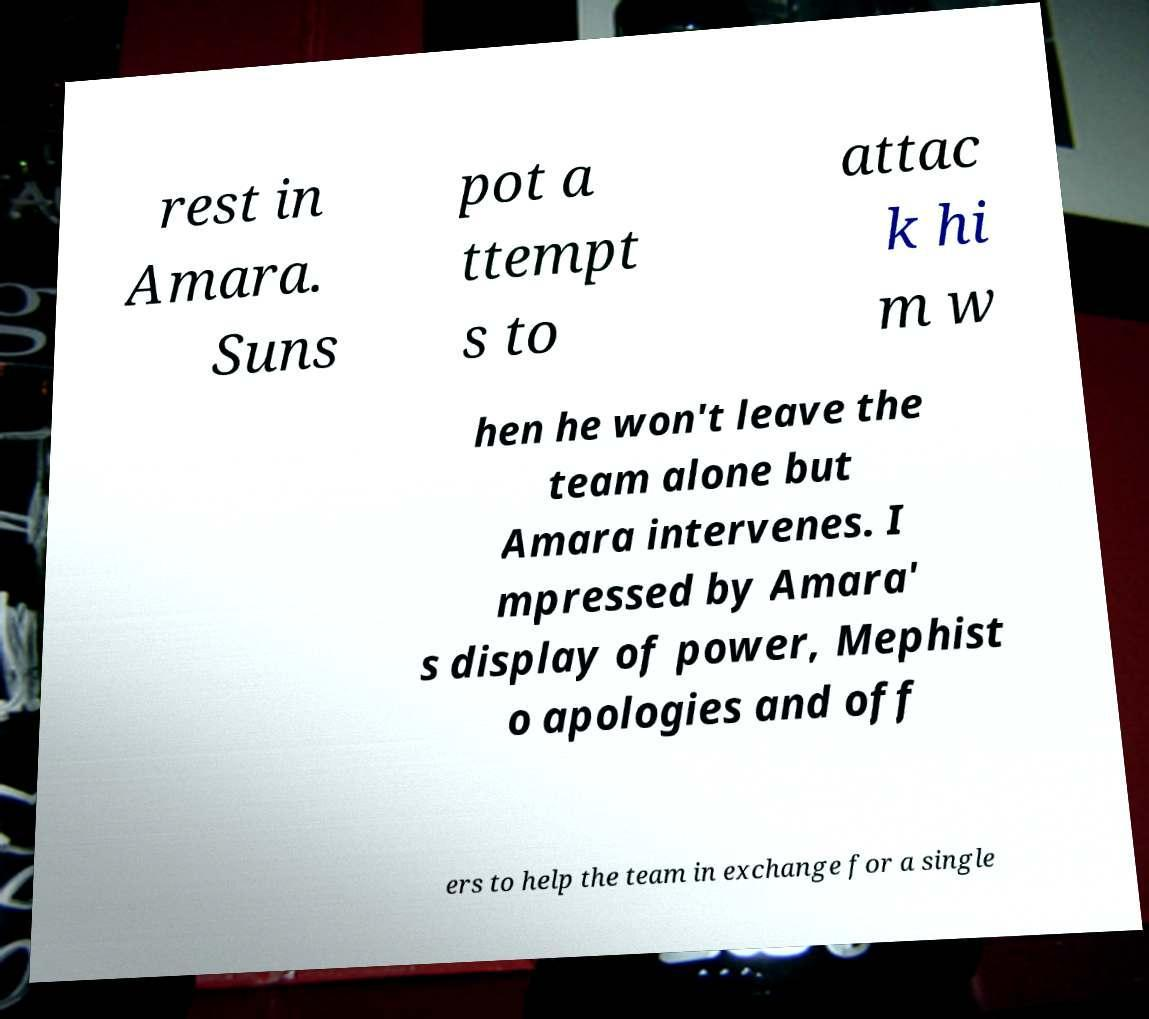For documentation purposes, I need the text within this image transcribed. Could you provide that? rest in Amara. Suns pot a ttempt s to attac k hi m w hen he won't leave the team alone but Amara intervenes. I mpressed by Amara' s display of power, Mephist o apologies and off ers to help the team in exchange for a single 